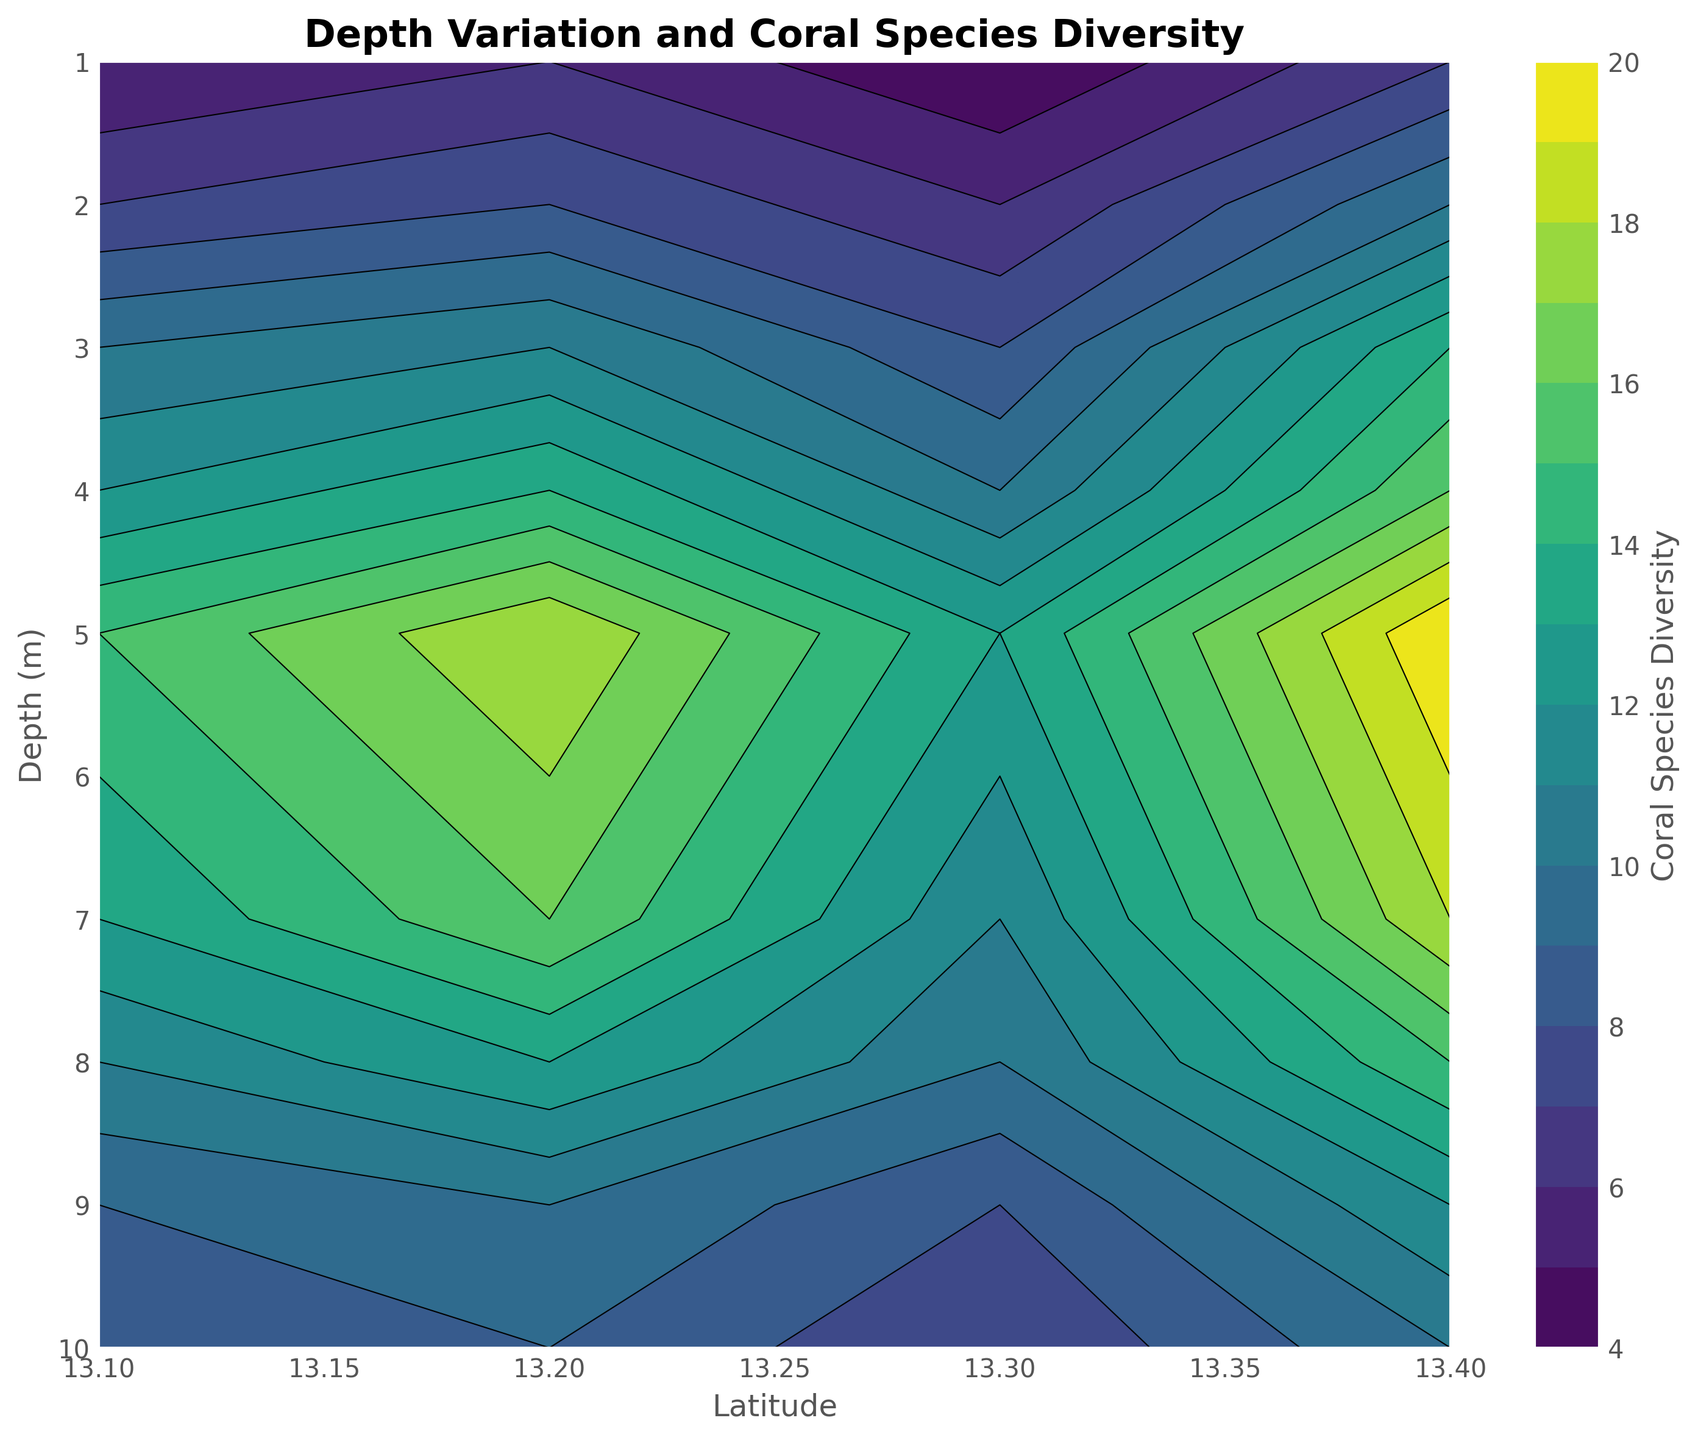What is the coral species diversity at a depth of 5 meters and a latitude of 13.2? To find the coral species diversity, locate the point where the depth is 5 meters (y-axis) and the latitude is 13.2 (x-axis).
Answer: 18 At what depth and latitude is the coral species diversity highest? Scan the contour plot to find the highest color intensity, indicating the highest coral species diversity. Refer to the corresponding depth and latitude.
Answer: Depth: 5m, Latitude: 13.4 Does the coral species diversity tend to increase or decrease with depth at latitude 13.1? Examine the contour plot at latitude 13.1, observing how the color changes from the top (shallow depth) to the bottom (greater depth). Identify whether the color intensity indicates increasing or decreasing diversity with depth.
Answer: Increases up to 5m, then decreases Which latitude shows the highest coral species diversity at shallow depths? Compare the color intensities for shallow depths (1-3 meters) across all latitudes. Identify the latitude where the highest color intensity is observed.
Answer: 13.4 Is the coral species diversity more uniform across depths at latitude 13.3 or 13.2? Compare the contour lines for latitudes 13.3 and 13.2. Uniformity is indicated by less variation in the contour line spacing and color changes across depths.
Answer: 13.3 What is the average coral species diversity at a depth of 7 meters across all latitudes? Identify the data points for a depth of 7 meters across all latitudes. Calculate their average value.
Answer: 14.5 How does the coral species diversity at 6 meters depth compare between latitudes 13.1 and 13.4? Locate the coral species diversity values at 6 meters depth for latitudes 13.1 and 13.4. Compare the two values.
Answer: 14 at 13.1, 19 at 13.4 What is the range of coral species diversity values observed at a latitude of 13.2? Identify the minimum and maximum coral species diversity values for latitude 13.2 by scanning the plot. Subtract the minimum from the maximum to determine the range.
Answer: Range is 18-6 = 12 Which depth shows the least variability in coral species diversity at all latitudes? Look for the depth where the contour lines are most parallel and evenly spaced across all latitudes, indicating minimal variability.
Answer: 10 meters What latitude shows the steepest change in coral species diversity with depth? Identify the latitude where the contour lines are closest together, indicating a steep gradient or change in coral species diversity with depth.
Answer: 13.4 